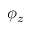Convert formula to latex. <formula><loc_0><loc_0><loc_500><loc_500>\phi _ { z }</formula> 